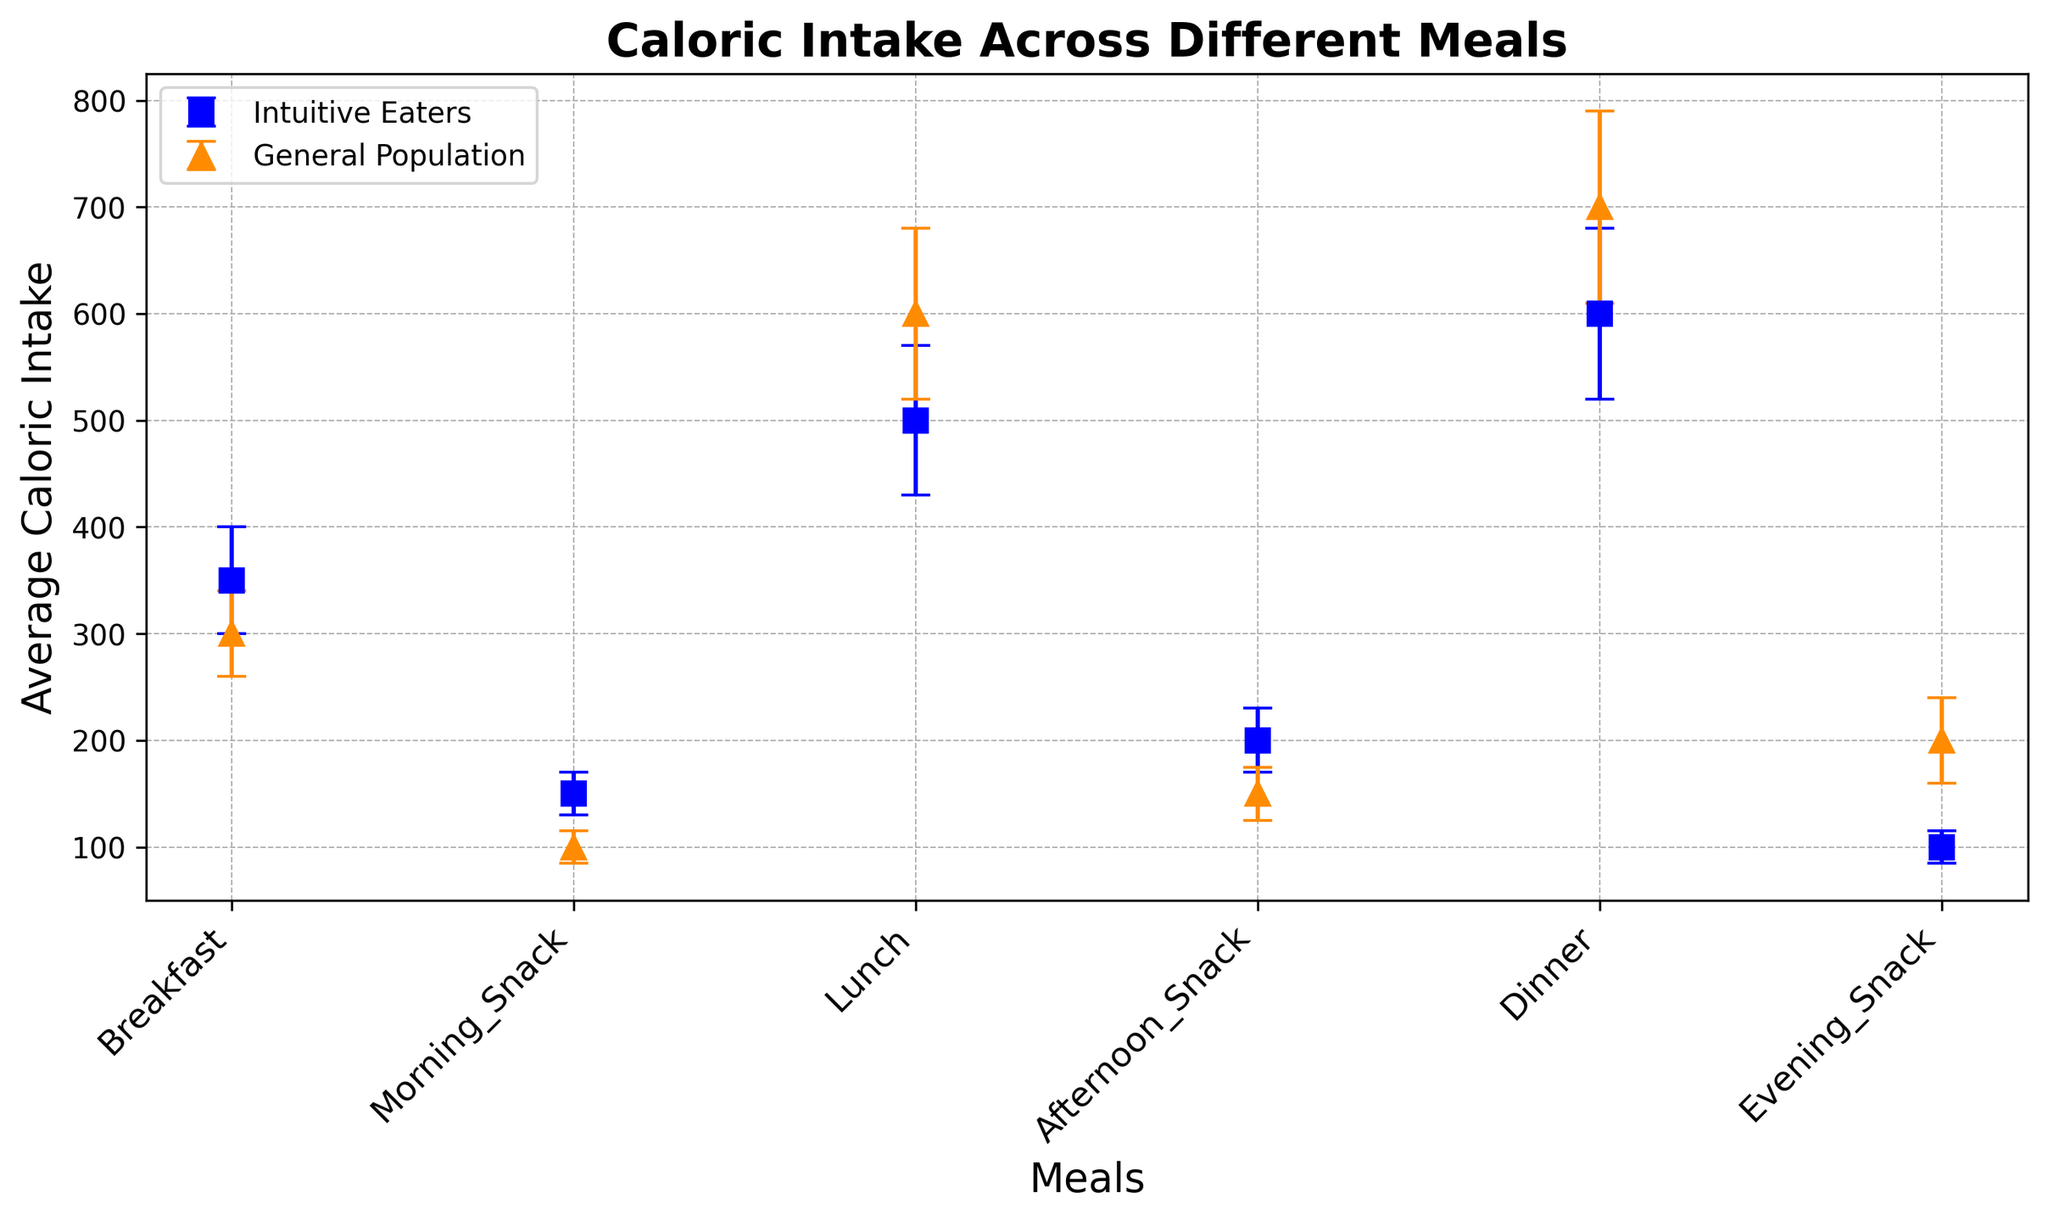What's the average difference in caloric intake between Intuitive Eaters and the General Population during breakfast? To find the average difference, subtract the average caloric intake of the General Population from Intuitive Eaters for breakfast. This is 350 - 300 = 50 calories.
Answer: 50 calories During which meal do Intuitive Eaters consume the least calories? Reviewing the caloric intake for Intuitive Eaters across all meals, the meal with the lowest value is the Evening Snack at 100 calories.
Answer: Evening Snack Compare the standard deviations of the caloric intake in the Afternoon Snack for both groups. Which group shows greater variability? Looking at the standard deviations for Afternoon Snack, Intuitive Eaters have a standard deviation of 30, while the General Population has 25. Therefore, Intuitive Eaters show more variability.
Answer: Intuitive Eaters How much more caloric intake do General Population individuals consume on average during Evening Snack compared to Intuitive Eaters? Find the difference in caloric intake during Evening Snack between the two groups: 200 - 100 = 100 calories more.
Answer: 100 calories more Which group has a higher average caloric intake during lunch, and by how much? Compare the caloric intake during lunch, where Intuitive Eaters have 500 calories and the General Population has 600 calories. The General Population consumes 600 - 500 = 100 calories more.
Answer: General Population by 100 calories During which meal do Intuitive Eaters consume approximately the same number of calories as the General Population? Reviewing all the meals, breakfast is the closest, with Intuitive Eaters consuming 350 calories and the General Population consuming 300 calories, showing a relatively small difference.
Answer: Breakfast On which meals does the General Population have higher average caloric intake than Intuitive Eaters? Compare each meal: Lunch, Dinner, and Evening Snack have higher caloric intake in the General Population compared to Intuitive Eaters (600 vs 500, 700 vs 600, and 200 vs 100, respectively).
Answer: Lunch, Dinner, Evening Snack What is the total average caloric intake for Intuitive Eaters and the General Population over the entire day? Sum the average caloric intakes for all meals for both communities: Intuitive Eaters: 350 + 150 + 500 + 200 + 600 + 100 = 1900, General Population: 300 + 100 + 600 + 150 + 700 + 200 = 2050.
Answer: Intuitive Eaters: 1900, General Population: 2050 Which meal shows the greatest difference in average caloric intake between Intuitive Eaters and the General Population, and what is that difference? The evening snack shows the greatest difference. Calculate it as 200 - 100 = 100 calories.
Answer: Evening Snack, 100 calories 